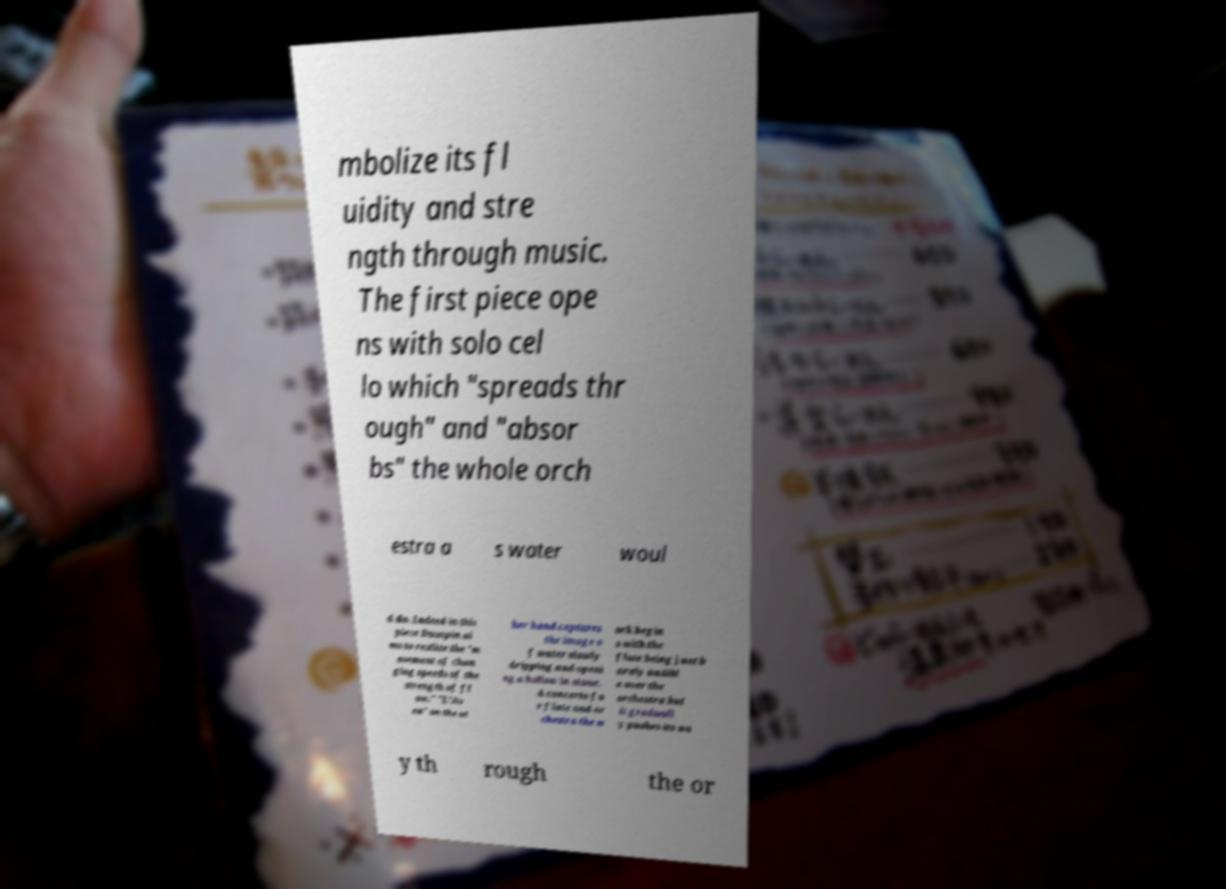There's text embedded in this image that I need extracted. Can you transcribe it verbatim? mbolize its fl uidity and stre ngth through music. The first piece ope ns with solo cel lo which "spreads thr ough" and "absor bs" the whole orch estra a s water woul d do. Indeed in this piece Dusapin ai ms to realize the "m ovement of chan ging speeds of the strength of fl ow." "L’Av en" on the ot her hand captures the image o f water slowly dripping and openi ng a hollow in stone. A concerto fo r flute and or chestra the w ork begin s with the flute being just b arely audibl e over the orchestra but it graduall y pushes its wa y th rough the or 